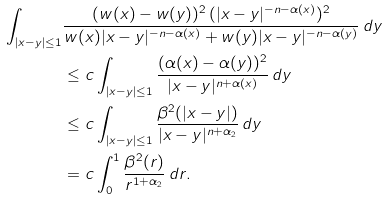<formula> <loc_0><loc_0><loc_500><loc_500>\int _ { | x - y | \leq 1 } & \frac { ( w ( x ) - w ( y ) ) ^ { 2 } \, ( | x - y | ^ { - n - \alpha ( x ) } ) ^ { 2 } } { w ( x ) | x - y | ^ { - n - \alpha ( x ) } + w ( y ) | x - y | ^ { - n - \alpha ( y ) } } \, d y \\ & \leq c \int _ { | x - y | \leq 1 } \frac { ( \alpha ( x ) - \alpha ( y ) ) ^ { 2 } } { | x - y | ^ { n + \alpha ( x ) } } \, d y \\ & \leq c \int _ { | x - y | \leq 1 } \frac { \beta ^ { 2 } ( | x - y | ) } { | x - y | ^ { n + \alpha _ { 2 } } } \, d y \\ & = c \int _ { 0 } ^ { 1 } \frac { \beta ^ { 2 } ( r ) } { r ^ { 1 + \alpha _ { 2 } } } \, d r .</formula> 